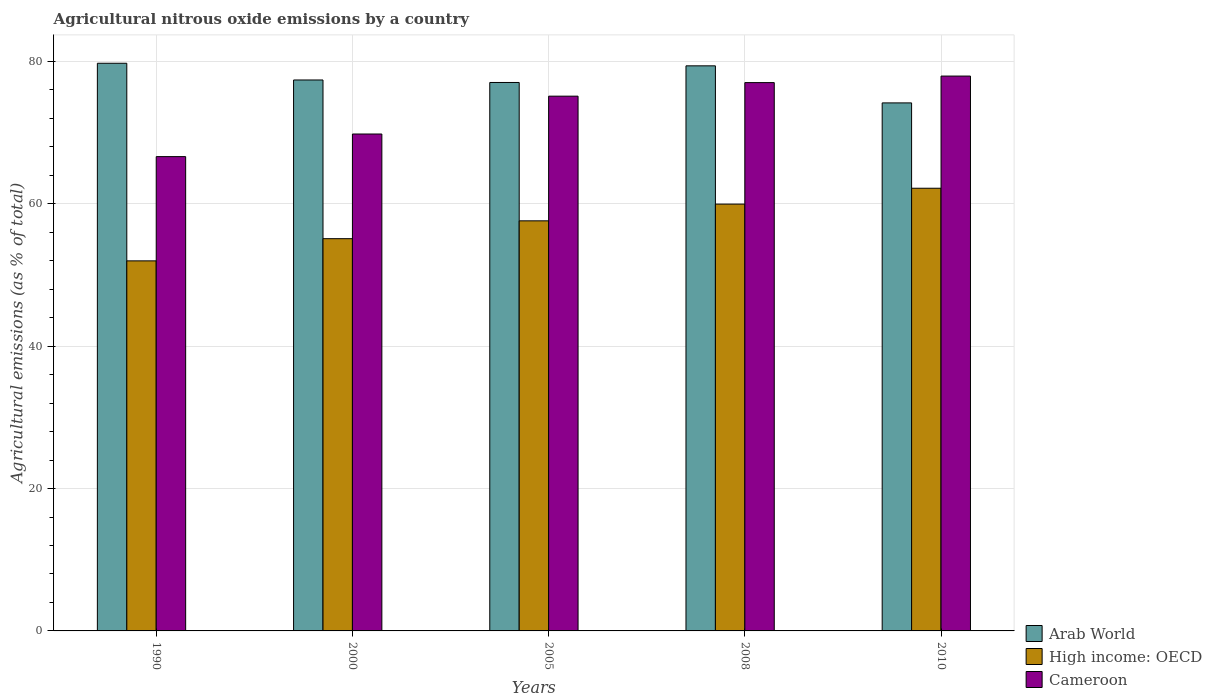How many different coloured bars are there?
Your response must be concise. 3. How many groups of bars are there?
Keep it short and to the point. 5. Are the number of bars per tick equal to the number of legend labels?
Ensure brevity in your answer.  Yes. Are the number of bars on each tick of the X-axis equal?
Your response must be concise. Yes. How many bars are there on the 2nd tick from the left?
Provide a succinct answer. 3. How many bars are there on the 1st tick from the right?
Provide a succinct answer. 3. What is the amount of agricultural nitrous oxide emitted in Arab World in 2010?
Keep it short and to the point. 74.18. Across all years, what is the maximum amount of agricultural nitrous oxide emitted in Cameroon?
Offer a terse response. 77.95. Across all years, what is the minimum amount of agricultural nitrous oxide emitted in Cameroon?
Make the answer very short. 66.63. In which year was the amount of agricultural nitrous oxide emitted in High income: OECD maximum?
Keep it short and to the point. 2010. In which year was the amount of agricultural nitrous oxide emitted in Arab World minimum?
Your answer should be compact. 2010. What is the total amount of agricultural nitrous oxide emitted in Arab World in the graph?
Your response must be concise. 387.77. What is the difference between the amount of agricultural nitrous oxide emitted in Arab World in 2000 and that in 2008?
Provide a succinct answer. -1.99. What is the difference between the amount of agricultural nitrous oxide emitted in Cameroon in 2000 and the amount of agricultural nitrous oxide emitted in High income: OECD in 1990?
Offer a terse response. 17.82. What is the average amount of agricultural nitrous oxide emitted in Arab World per year?
Provide a short and direct response. 77.55. In the year 2000, what is the difference between the amount of agricultural nitrous oxide emitted in Cameroon and amount of agricultural nitrous oxide emitted in High income: OECD?
Provide a short and direct response. 14.71. In how many years, is the amount of agricultural nitrous oxide emitted in Arab World greater than 16 %?
Ensure brevity in your answer.  5. What is the ratio of the amount of agricultural nitrous oxide emitted in Arab World in 2000 to that in 2010?
Keep it short and to the point. 1.04. Is the difference between the amount of agricultural nitrous oxide emitted in Cameroon in 1990 and 2000 greater than the difference between the amount of agricultural nitrous oxide emitted in High income: OECD in 1990 and 2000?
Provide a short and direct response. No. What is the difference between the highest and the second highest amount of agricultural nitrous oxide emitted in High income: OECD?
Keep it short and to the point. 2.23. What is the difference between the highest and the lowest amount of agricultural nitrous oxide emitted in Cameroon?
Keep it short and to the point. 11.31. In how many years, is the amount of agricultural nitrous oxide emitted in High income: OECD greater than the average amount of agricultural nitrous oxide emitted in High income: OECD taken over all years?
Provide a short and direct response. 3. Is the sum of the amount of agricultural nitrous oxide emitted in High income: OECD in 2000 and 2008 greater than the maximum amount of agricultural nitrous oxide emitted in Arab World across all years?
Make the answer very short. Yes. What does the 1st bar from the left in 2008 represents?
Your answer should be very brief. Arab World. What does the 1st bar from the right in 2005 represents?
Keep it short and to the point. Cameroon. How many years are there in the graph?
Ensure brevity in your answer.  5. What is the difference between two consecutive major ticks on the Y-axis?
Your answer should be very brief. 20. Are the values on the major ticks of Y-axis written in scientific E-notation?
Your answer should be compact. No. Does the graph contain grids?
Provide a short and direct response. Yes. Where does the legend appear in the graph?
Make the answer very short. Bottom right. How many legend labels are there?
Offer a terse response. 3. How are the legend labels stacked?
Keep it short and to the point. Vertical. What is the title of the graph?
Your answer should be compact. Agricultural nitrous oxide emissions by a country. What is the label or title of the X-axis?
Ensure brevity in your answer.  Years. What is the label or title of the Y-axis?
Make the answer very short. Agricultural emissions (as % of total). What is the Agricultural emissions (as % of total) in Arab World in 1990?
Give a very brief answer. 79.75. What is the Agricultural emissions (as % of total) of High income: OECD in 1990?
Your answer should be compact. 51.99. What is the Agricultural emissions (as % of total) in Cameroon in 1990?
Offer a terse response. 66.63. What is the Agricultural emissions (as % of total) in Arab World in 2000?
Provide a succinct answer. 77.4. What is the Agricultural emissions (as % of total) of High income: OECD in 2000?
Ensure brevity in your answer.  55.1. What is the Agricultural emissions (as % of total) of Cameroon in 2000?
Your answer should be very brief. 69.81. What is the Agricultural emissions (as % of total) in Arab World in 2005?
Your answer should be very brief. 77.05. What is the Agricultural emissions (as % of total) of High income: OECD in 2005?
Provide a short and direct response. 57.61. What is the Agricultural emissions (as % of total) in Cameroon in 2005?
Offer a terse response. 75.13. What is the Agricultural emissions (as % of total) in Arab World in 2008?
Provide a short and direct response. 79.39. What is the Agricultural emissions (as % of total) of High income: OECD in 2008?
Your answer should be very brief. 59.96. What is the Agricultural emissions (as % of total) in Cameroon in 2008?
Ensure brevity in your answer.  77.03. What is the Agricultural emissions (as % of total) in Arab World in 2010?
Make the answer very short. 74.18. What is the Agricultural emissions (as % of total) in High income: OECD in 2010?
Offer a very short reply. 62.19. What is the Agricultural emissions (as % of total) in Cameroon in 2010?
Give a very brief answer. 77.95. Across all years, what is the maximum Agricultural emissions (as % of total) in Arab World?
Make the answer very short. 79.75. Across all years, what is the maximum Agricultural emissions (as % of total) in High income: OECD?
Give a very brief answer. 62.19. Across all years, what is the maximum Agricultural emissions (as % of total) in Cameroon?
Your answer should be very brief. 77.95. Across all years, what is the minimum Agricultural emissions (as % of total) in Arab World?
Your response must be concise. 74.18. Across all years, what is the minimum Agricultural emissions (as % of total) in High income: OECD?
Your answer should be very brief. 51.99. Across all years, what is the minimum Agricultural emissions (as % of total) of Cameroon?
Offer a terse response. 66.63. What is the total Agricultural emissions (as % of total) of Arab World in the graph?
Provide a short and direct response. 387.77. What is the total Agricultural emissions (as % of total) in High income: OECD in the graph?
Keep it short and to the point. 286.86. What is the total Agricultural emissions (as % of total) in Cameroon in the graph?
Offer a very short reply. 366.55. What is the difference between the Agricultural emissions (as % of total) of Arab World in 1990 and that in 2000?
Make the answer very short. 2.35. What is the difference between the Agricultural emissions (as % of total) of High income: OECD in 1990 and that in 2000?
Your answer should be compact. -3.12. What is the difference between the Agricultural emissions (as % of total) in Cameroon in 1990 and that in 2000?
Your answer should be compact. -3.18. What is the difference between the Agricultural emissions (as % of total) of Arab World in 1990 and that in 2005?
Provide a succinct answer. 2.7. What is the difference between the Agricultural emissions (as % of total) of High income: OECD in 1990 and that in 2005?
Keep it short and to the point. -5.62. What is the difference between the Agricultural emissions (as % of total) in Cameroon in 1990 and that in 2005?
Provide a short and direct response. -8.49. What is the difference between the Agricultural emissions (as % of total) of Arab World in 1990 and that in 2008?
Give a very brief answer. 0.36. What is the difference between the Agricultural emissions (as % of total) of High income: OECD in 1990 and that in 2008?
Your answer should be compact. -7.97. What is the difference between the Agricultural emissions (as % of total) of Cameroon in 1990 and that in 2008?
Your response must be concise. -10.4. What is the difference between the Agricultural emissions (as % of total) of Arab World in 1990 and that in 2010?
Give a very brief answer. 5.57. What is the difference between the Agricultural emissions (as % of total) of High income: OECD in 1990 and that in 2010?
Your answer should be compact. -10.2. What is the difference between the Agricultural emissions (as % of total) of Cameroon in 1990 and that in 2010?
Make the answer very short. -11.31. What is the difference between the Agricultural emissions (as % of total) of Arab World in 2000 and that in 2005?
Provide a short and direct response. 0.35. What is the difference between the Agricultural emissions (as % of total) of High income: OECD in 2000 and that in 2005?
Provide a short and direct response. -2.51. What is the difference between the Agricultural emissions (as % of total) in Cameroon in 2000 and that in 2005?
Ensure brevity in your answer.  -5.32. What is the difference between the Agricultural emissions (as % of total) in Arab World in 2000 and that in 2008?
Offer a very short reply. -1.99. What is the difference between the Agricultural emissions (as % of total) in High income: OECD in 2000 and that in 2008?
Offer a terse response. -4.86. What is the difference between the Agricultural emissions (as % of total) in Cameroon in 2000 and that in 2008?
Ensure brevity in your answer.  -7.22. What is the difference between the Agricultural emissions (as % of total) in Arab World in 2000 and that in 2010?
Keep it short and to the point. 3.22. What is the difference between the Agricultural emissions (as % of total) in High income: OECD in 2000 and that in 2010?
Ensure brevity in your answer.  -7.09. What is the difference between the Agricultural emissions (as % of total) in Cameroon in 2000 and that in 2010?
Offer a terse response. -8.14. What is the difference between the Agricultural emissions (as % of total) of Arab World in 2005 and that in 2008?
Offer a terse response. -2.34. What is the difference between the Agricultural emissions (as % of total) in High income: OECD in 2005 and that in 2008?
Keep it short and to the point. -2.35. What is the difference between the Agricultural emissions (as % of total) in Cameroon in 2005 and that in 2008?
Give a very brief answer. -1.9. What is the difference between the Agricultural emissions (as % of total) in Arab World in 2005 and that in 2010?
Provide a succinct answer. 2.87. What is the difference between the Agricultural emissions (as % of total) in High income: OECD in 2005 and that in 2010?
Give a very brief answer. -4.58. What is the difference between the Agricultural emissions (as % of total) in Cameroon in 2005 and that in 2010?
Give a very brief answer. -2.82. What is the difference between the Agricultural emissions (as % of total) in Arab World in 2008 and that in 2010?
Your answer should be compact. 5.21. What is the difference between the Agricultural emissions (as % of total) of High income: OECD in 2008 and that in 2010?
Offer a very short reply. -2.23. What is the difference between the Agricultural emissions (as % of total) of Cameroon in 2008 and that in 2010?
Keep it short and to the point. -0.92. What is the difference between the Agricultural emissions (as % of total) of Arab World in 1990 and the Agricultural emissions (as % of total) of High income: OECD in 2000?
Offer a terse response. 24.65. What is the difference between the Agricultural emissions (as % of total) of Arab World in 1990 and the Agricultural emissions (as % of total) of Cameroon in 2000?
Your answer should be very brief. 9.94. What is the difference between the Agricultural emissions (as % of total) of High income: OECD in 1990 and the Agricultural emissions (as % of total) of Cameroon in 2000?
Your response must be concise. -17.82. What is the difference between the Agricultural emissions (as % of total) of Arab World in 1990 and the Agricultural emissions (as % of total) of High income: OECD in 2005?
Offer a very short reply. 22.14. What is the difference between the Agricultural emissions (as % of total) of Arab World in 1990 and the Agricultural emissions (as % of total) of Cameroon in 2005?
Provide a succinct answer. 4.62. What is the difference between the Agricultural emissions (as % of total) of High income: OECD in 1990 and the Agricultural emissions (as % of total) of Cameroon in 2005?
Ensure brevity in your answer.  -23.14. What is the difference between the Agricultural emissions (as % of total) in Arab World in 1990 and the Agricultural emissions (as % of total) in High income: OECD in 2008?
Your response must be concise. 19.79. What is the difference between the Agricultural emissions (as % of total) in Arab World in 1990 and the Agricultural emissions (as % of total) in Cameroon in 2008?
Your answer should be very brief. 2.72. What is the difference between the Agricultural emissions (as % of total) in High income: OECD in 1990 and the Agricultural emissions (as % of total) in Cameroon in 2008?
Make the answer very short. -25.04. What is the difference between the Agricultural emissions (as % of total) in Arab World in 1990 and the Agricultural emissions (as % of total) in High income: OECD in 2010?
Ensure brevity in your answer.  17.56. What is the difference between the Agricultural emissions (as % of total) in Arab World in 1990 and the Agricultural emissions (as % of total) in Cameroon in 2010?
Your answer should be compact. 1.8. What is the difference between the Agricultural emissions (as % of total) of High income: OECD in 1990 and the Agricultural emissions (as % of total) of Cameroon in 2010?
Keep it short and to the point. -25.96. What is the difference between the Agricultural emissions (as % of total) in Arab World in 2000 and the Agricultural emissions (as % of total) in High income: OECD in 2005?
Give a very brief answer. 19.79. What is the difference between the Agricultural emissions (as % of total) in Arab World in 2000 and the Agricultural emissions (as % of total) in Cameroon in 2005?
Make the answer very short. 2.27. What is the difference between the Agricultural emissions (as % of total) of High income: OECD in 2000 and the Agricultural emissions (as % of total) of Cameroon in 2005?
Offer a very short reply. -20.02. What is the difference between the Agricultural emissions (as % of total) of Arab World in 2000 and the Agricultural emissions (as % of total) of High income: OECD in 2008?
Keep it short and to the point. 17.44. What is the difference between the Agricultural emissions (as % of total) of Arab World in 2000 and the Agricultural emissions (as % of total) of Cameroon in 2008?
Provide a short and direct response. 0.37. What is the difference between the Agricultural emissions (as % of total) in High income: OECD in 2000 and the Agricultural emissions (as % of total) in Cameroon in 2008?
Your response must be concise. -21.93. What is the difference between the Agricultural emissions (as % of total) in Arab World in 2000 and the Agricultural emissions (as % of total) in High income: OECD in 2010?
Provide a short and direct response. 15.21. What is the difference between the Agricultural emissions (as % of total) of Arab World in 2000 and the Agricultural emissions (as % of total) of Cameroon in 2010?
Ensure brevity in your answer.  -0.55. What is the difference between the Agricultural emissions (as % of total) of High income: OECD in 2000 and the Agricultural emissions (as % of total) of Cameroon in 2010?
Make the answer very short. -22.84. What is the difference between the Agricultural emissions (as % of total) of Arab World in 2005 and the Agricultural emissions (as % of total) of High income: OECD in 2008?
Keep it short and to the point. 17.09. What is the difference between the Agricultural emissions (as % of total) of Arab World in 2005 and the Agricultural emissions (as % of total) of Cameroon in 2008?
Provide a short and direct response. 0.02. What is the difference between the Agricultural emissions (as % of total) of High income: OECD in 2005 and the Agricultural emissions (as % of total) of Cameroon in 2008?
Make the answer very short. -19.42. What is the difference between the Agricultural emissions (as % of total) of Arab World in 2005 and the Agricultural emissions (as % of total) of High income: OECD in 2010?
Your response must be concise. 14.86. What is the difference between the Agricultural emissions (as % of total) of Arab World in 2005 and the Agricultural emissions (as % of total) of Cameroon in 2010?
Make the answer very short. -0.9. What is the difference between the Agricultural emissions (as % of total) of High income: OECD in 2005 and the Agricultural emissions (as % of total) of Cameroon in 2010?
Offer a terse response. -20.34. What is the difference between the Agricultural emissions (as % of total) in Arab World in 2008 and the Agricultural emissions (as % of total) in High income: OECD in 2010?
Keep it short and to the point. 17.2. What is the difference between the Agricultural emissions (as % of total) of Arab World in 2008 and the Agricultural emissions (as % of total) of Cameroon in 2010?
Make the answer very short. 1.44. What is the difference between the Agricultural emissions (as % of total) in High income: OECD in 2008 and the Agricultural emissions (as % of total) in Cameroon in 2010?
Provide a succinct answer. -17.99. What is the average Agricultural emissions (as % of total) of Arab World per year?
Offer a very short reply. 77.55. What is the average Agricultural emissions (as % of total) in High income: OECD per year?
Offer a very short reply. 57.37. What is the average Agricultural emissions (as % of total) in Cameroon per year?
Offer a very short reply. 73.31. In the year 1990, what is the difference between the Agricultural emissions (as % of total) in Arab World and Agricultural emissions (as % of total) in High income: OECD?
Provide a short and direct response. 27.76. In the year 1990, what is the difference between the Agricultural emissions (as % of total) in Arab World and Agricultural emissions (as % of total) in Cameroon?
Ensure brevity in your answer.  13.12. In the year 1990, what is the difference between the Agricultural emissions (as % of total) of High income: OECD and Agricultural emissions (as % of total) of Cameroon?
Make the answer very short. -14.65. In the year 2000, what is the difference between the Agricultural emissions (as % of total) of Arab World and Agricultural emissions (as % of total) of High income: OECD?
Offer a terse response. 22.3. In the year 2000, what is the difference between the Agricultural emissions (as % of total) of Arab World and Agricultural emissions (as % of total) of Cameroon?
Provide a succinct answer. 7.59. In the year 2000, what is the difference between the Agricultural emissions (as % of total) of High income: OECD and Agricultural emissions (as % of total) of Cameroon?
Provide a short and direct response. -14.71. In the year 2005, what is the difference between the Agricultural emissions (as % of total) in Arab World and Agricultural emissions (as % of total) in High income: OECD?
Ensure brevity in your answer.  19.44. In the year 2005, what is the difference between the Agricultural emissions (as % of total) of Arab World and Agricultural emissions (as % of total) of Cameroon?
Ensure brevity in your answer.  1.92. In the year 2005, what is the difference between the Agricultural emissions (as % of total) in High income: OECD and Agricultural emissions (as % of total) in Cameroon?
Your answer should be compact. -17.52. In the year 2008, what is the difference between the Agricultural emissions (as % of total) of Arab World and Agricultural emissions (as % of total) of High income: OECD?
Provide a short and direct response. 19.42. In the year 2008, what is the difference between the Agricultural emissions (as % of total) of Arab World and Agricultural emissions (as % of total) of Cameroon?
Your answer should be very brief. 2.35. In the year 2008, what is the difference between the Agricultural emissions (as % of total) in High income: OECD and Agricultural emissions (as % of total) in Cameroon?
Give a very brief answer. -17.07. In the year 2010, what is the difference between the Agricultural emissions (as % of total) of Arab World and Agricultural emissions (as % of total) of High income: OECD?
Your answer should be very brief. 11.99. In the year 2010, what is the difference between the Agricultural emissions (as % of total) in Arab World and Agricultural emissions (as % of total) in Cameroon?
Offer a very short reply. -3.77. In the year 2010, what is the difference between the Agricultural emissions (as % of total) in High income: OECD and Agricultural emissions (as % of total) in Cameroon?
Provide a short and direct response. -15.76. What is the ratio of the Agricultural emissions (as % of total) of Arab World in 1990 to that in 2000?
Give a very brief answer. 1.03. What is the ratio of the Agricultural emissions (as % of total) in High income: OECD in 1990 to that in 2000?
Make the answer very short. 0.94. What is the ratio of the Agricultural emissions (as % of total) in Cameroon in 1990 to that in 2000?
Keep it short and to the point. 0.95. What is the ratio of the Agricultural emissions (as % of total) in Arab World in 1990 to that in 2005?
Your answer should be compact. 1.03. What is the ratio of the Agricultural emissions (as % of total) in High income: OECD in 1990 to that in 2005?
Your answer should be very brief. 0.9. What is the ratio of the Agricultural emissions (as % of total) in Cameroon in 1990 to that in 2005?
Ensure brevity in your answer.  0.89. What is the ratio of the Agricultural emissions (as % of total) of High income: OECD in 1990 to that in 2008?
Your response must be concise. 0.87. What is the ratio of the Agricultural emissions (as % of total) in Cameroon in 1990 to that in 2008?
Offer a terse response. 0.86. What is the ratio of the Agricultural emissions (as % of total) of Arab World in 1990 to that in 2010?
Ensure brevity in your answer.  1.08. What is the ratio of the Agricultural emissions (as % of total) of High income: OECD in 1990 to that in 2010?
Keep it short and to the point. 0.84. What is the ratio of the Agricultural emissions (as % of total) in Cameroon in 1990 to that in 2010?
Your answer should be compact. 0.85. What is the ratio of the Agricultural emissions (as % of total) in High income: OECD in 2000 to that in 2005?
Keep it short and to the point. 0.96. What is the ratio of the Agricultural emissions (as % of total) of Cameroon in 2000 to that in 2005?
Offer a terse response. 0.93. What is the ratio of the Agricultural emissions (as % of total) in Arab World in 2000 to that in 2008?
Your answer should be compact. 0.97. What is the ratio of the Agricultural emissions (as % of total) of High income: OECD in 2000 to that in 2008?
Your answer should be very brief. 0.92. What is the ratio of the Agricultural emissions (as % of total) in Cameroon in 2000 to that in 2008?
Offer a very short reply. 0.91. What is the ratio of the Agricultural emissions (as % of total) of Arab World in 2000 to that in 2010?
Your answer should be compact. 1.04. What is the ratio of the Agricultural emissions (as % of total) in High income: OECD in 2000 to that in 2010?
Keep it short and to the point. 0.89. What is the ratio of the Agricultural emissions (as % of total) in Cameroon in 2000 to that in 2010?
Give a very brief answer. 0.9. What is the ratio of the Agricultural emissions (as % of total) in Arab World in 2005 to that in 2008?
Your answer should be very brief. 0.97. What is the ratio of the Agricultural emissions (as % of total) of High income: OECD in 2005 to that in 2008?
Offer a very short reply. 0.96. What is the ratio of the Agricultural emissions (as % of total) of Cameroon in 2005 to that in 2008?
Your response must be concise. 0.98. What is the ratio of the Agricultural emissions (as % of total) of Arab World in 2005 to that in 2010?
Offer a terse response. 1.04. What is the ratio of the Agricultural emissions (as % of total) in High income: OECD in 2005 to that in 2010?
Ensure brevity in your answer.  0.93. What is the ratio of the Agricultural emissions (as % of total) of Cameroon in 2005 to that in 2010?
Your answer should be very brief. 0.96. What is the ratio of the Agricultural emissions (as % of total) in Arab World in 2008 to that in 2010?
Keep it short and to the point. 1.07. What is the ratio of the Agricultural emissions (as % of total) of High income: OECD in 2008 to that in 2010?
Give a very brief answer. 0.96. What is the ratio of the Agricultural emissions (as % of total) in Cameroon in 2008 to that in 2010?
Your answer should be very brief. 0.99. What is the difference between the highest and the second highest Agricultural emissions (as % of total) in Arab World?
Your response must be concise. 0.36. What is the difference between the highest and the second highest Agricultural emissions (as % of total) of High income: OECD?
Provide a succinct answer. 2.23. What is the difference between the highest and the second highest Agricultural emissions (as % of total) in Cameroon?
Offer a terse response. 0.92. What is the difference between the highest and the lowest Agricultural emissions (as % of total) in Arab World?
Your response must be concise. 5.57. What is the difference between the highest and the lowest Agricultural emissions (as % of total) in High income: OECD?
Offer a terse response. 10.2. What is the difference between the highest and the lowest Agricultural emissions (as % of total) in Cameroon?
Your answer should be compact. 11.31. 